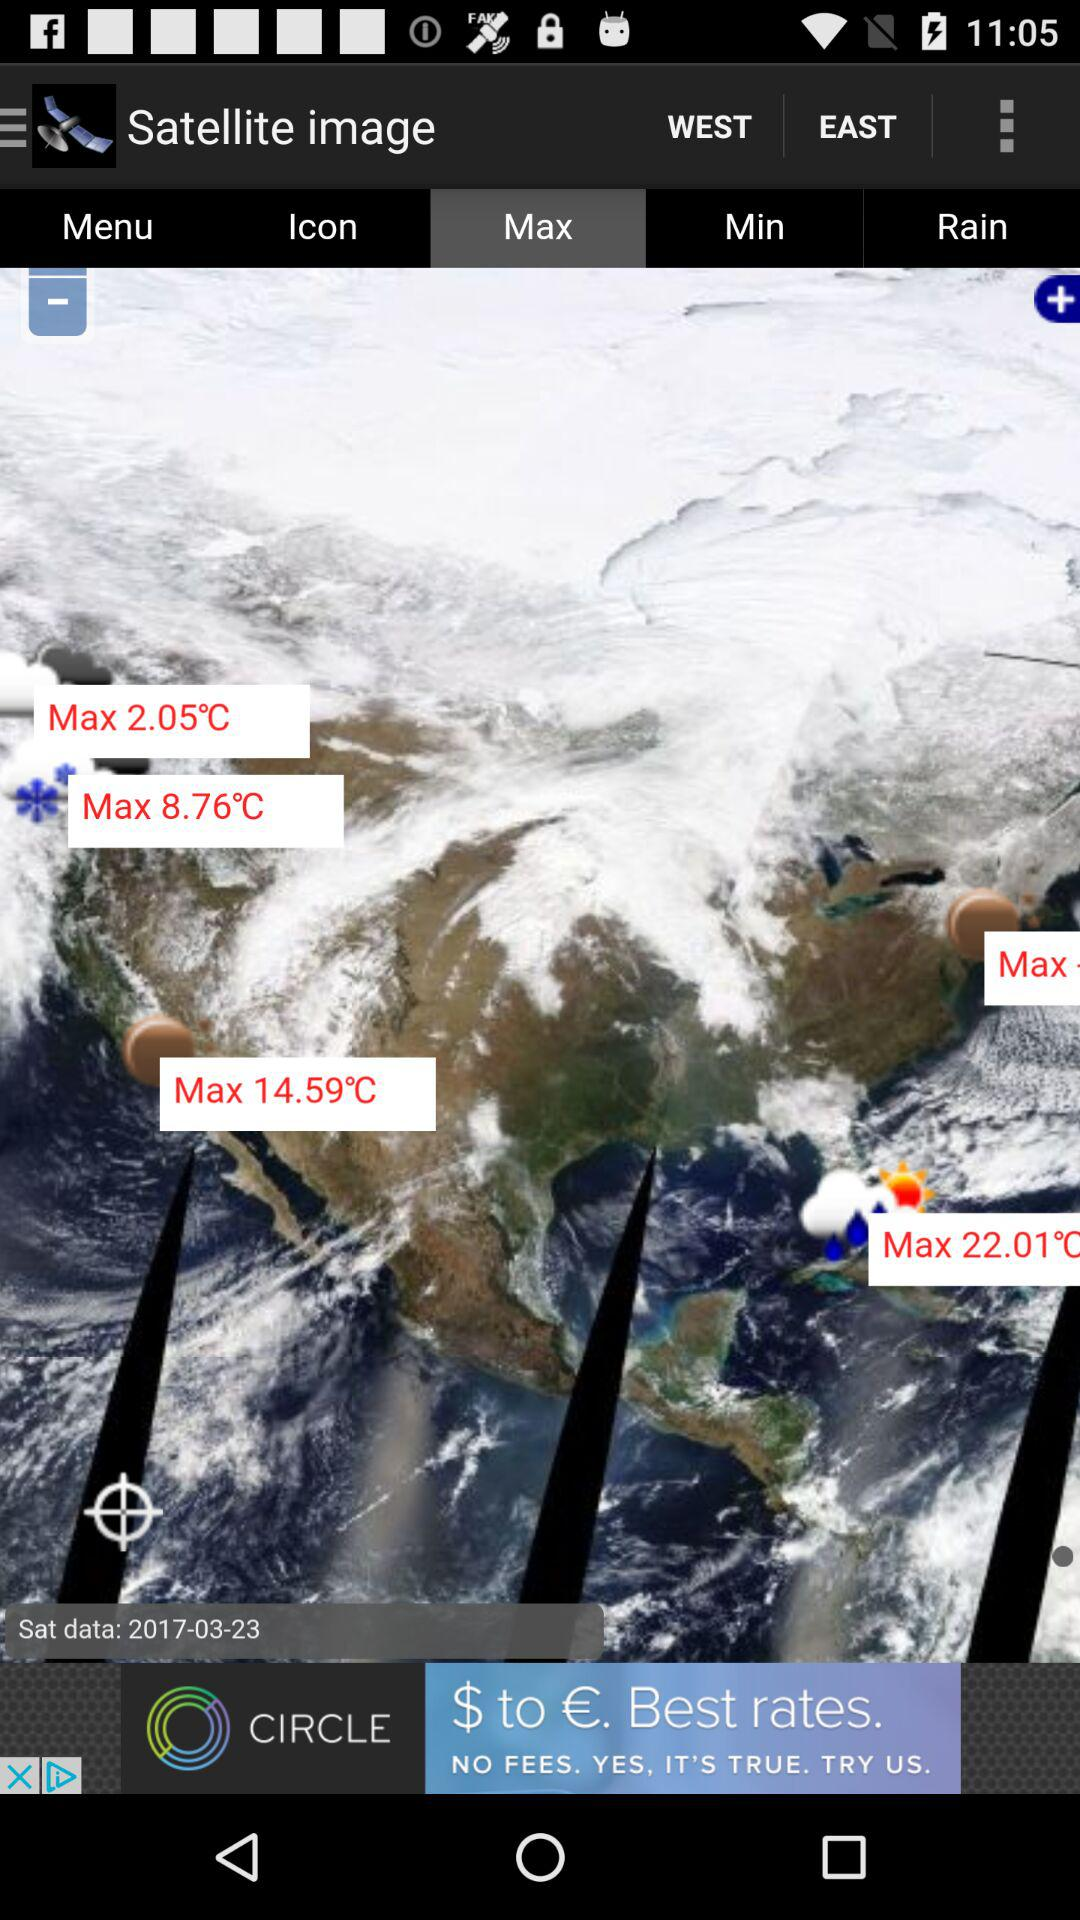Which option is selected in the "Satellite image"? The selected option in the "Satellite image" is "Max". 